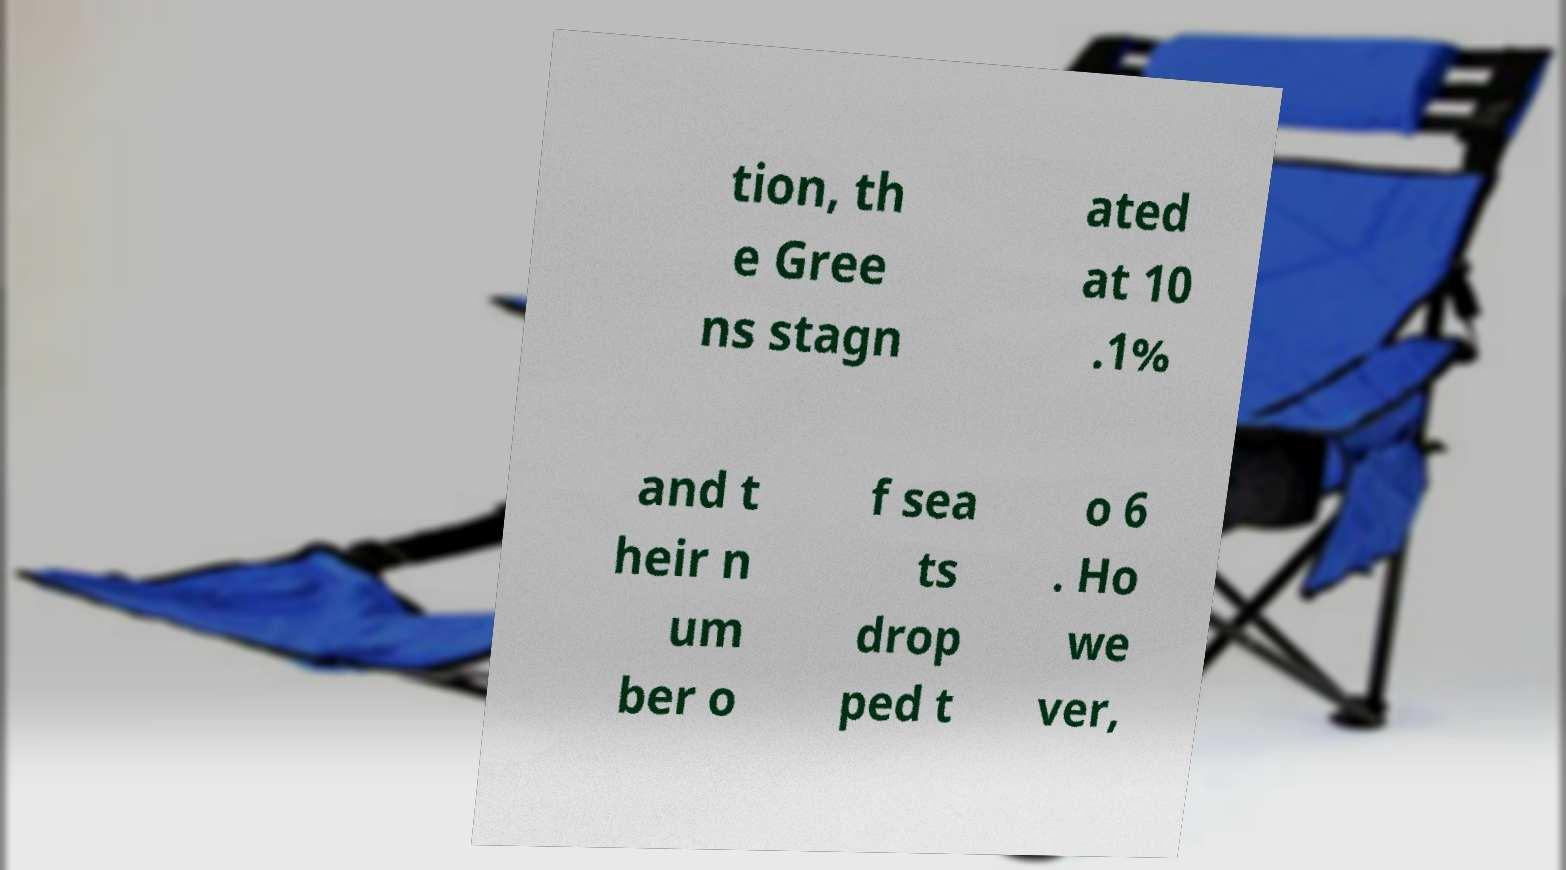There's text embedded in this image that I need extracted. Can you transcribe it verbatim? tion, th e Gree ns stagn ated at 10 .1% and t heir n um ber o f sea ts drop ped t o 6 . Ho we ver, 